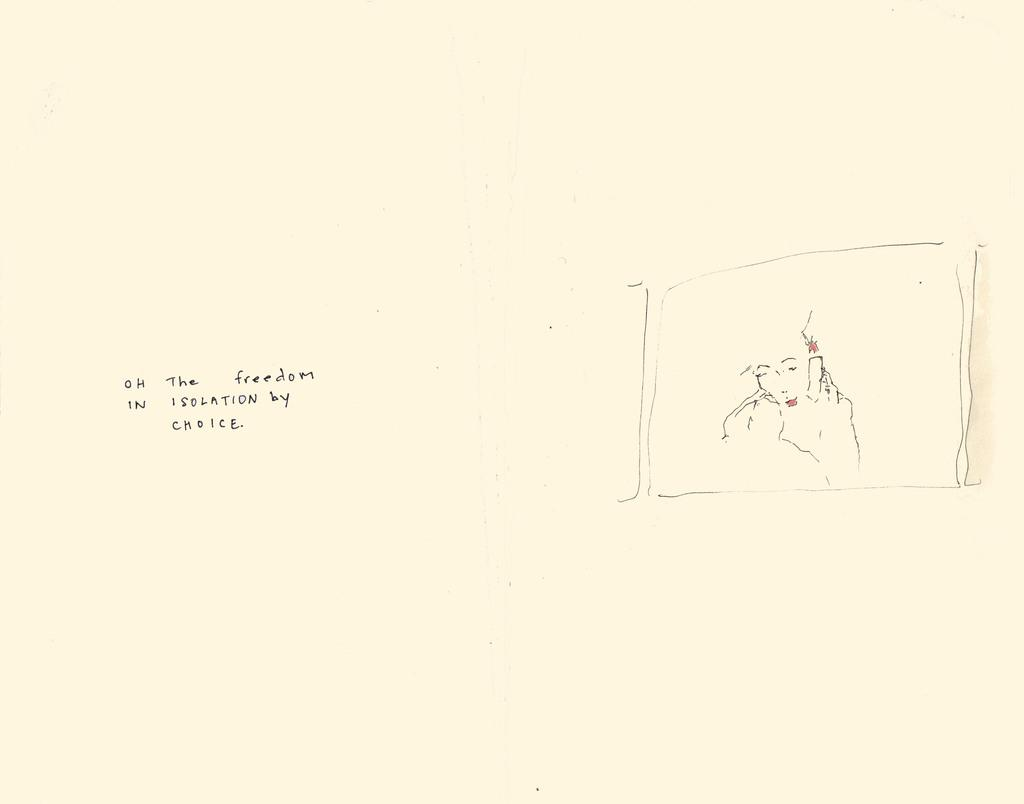What is the primary color of the surface in the image? The primary color of the surface in the image is white. What is depicted on the white surface? There is a drawing and text written on the white surface. Are there any squirrels visible on the white surface in the image? No, there are no squirrels present on the white surface in the image. Is there an island depicted on the white surface in the image? No, there is no island depicted on the white surface in the image. 